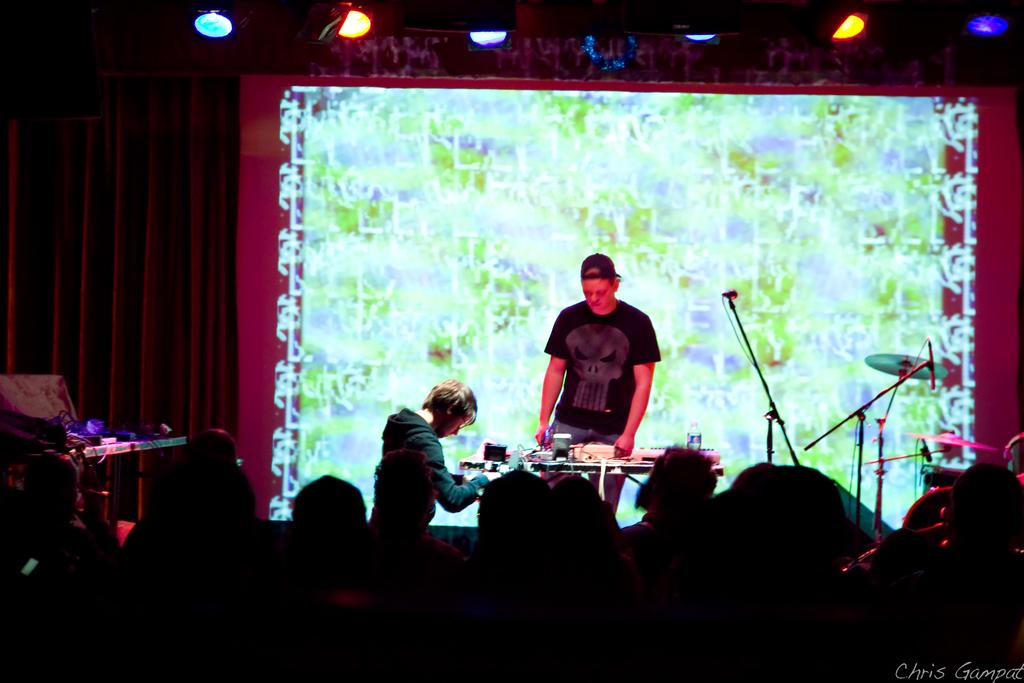Who or what can be seen in the image? There are people in the image. What is the purpose of the screen in the image? The screen's purpose is not specified, but it is present in the image. What type of lighting is present in the image? There are lights in the image. What type of furniture is present in the image? There are tables in the image. What musical instruments are present in the image? There are musical drums in the image. Can you describe the light source in the image? There is a light in the image. What is the tendency of the basin in the image? There is no basin present in the image, so it is not possible to determine its tendency. 